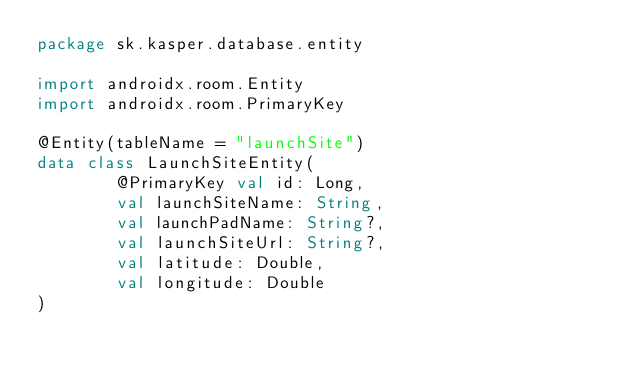Convert code to text. <code><loc_0><loc_0><loc_500><loc_500><_Kotlin_>package sk.kasper.database.entity

import androidx.room.Entity
import androidx.room.PrimaryKey

@Entity(tableName = "launchSite")
data class LaunchSiteEntity(
        @PrimaryKey val id: Long,
        val launchSiteName: String,
        val launchPadName: String?,
        val launchSiteUrl: String?,
        val latitude: Double,
        val longitude: Double
)</code> 